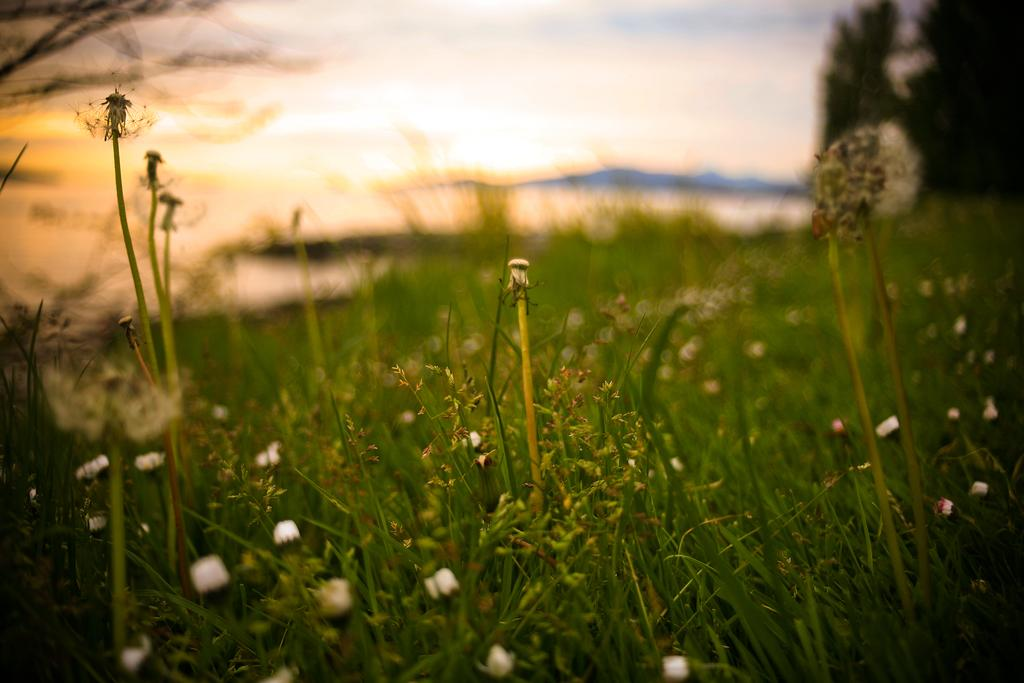What type of plants can be seen in the image? There are plants with tiny flowers in the image. Can you describe the background of the image? The background appears blurry in the image. What is the nature of the plants in the image? The plants may be trees, but this is not explicitly confirmed in the transcript. What language is being spoken by the plants in the image? There are no people or voices present in the image, so it is not possible to determine what language might be spoken. 